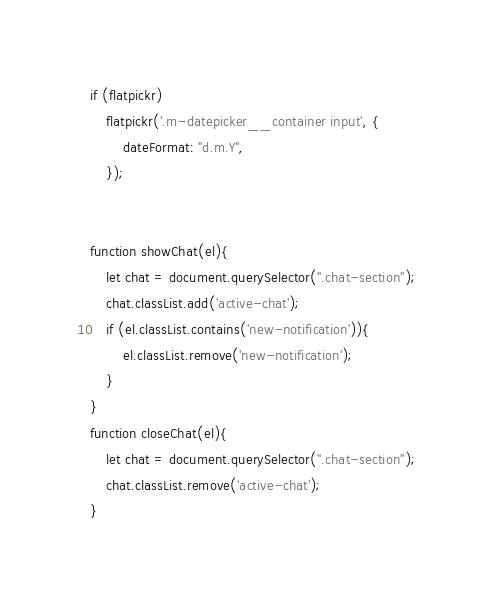Convert code to text. <code><loc_0><loc_0><loc_500><loc_500><_JavaScript_>if (flatpickr)
    flatpickr('.m-datepicker__container input', {
        dateFormat: "d.m.Y",
    });


function showChat(el){
    let chat = document.querySelector(".chat-section");
    chat.classList.add('active-chat');
    if (el.classList.contains('new-notification')){
        el.classList.remove('new-notification');
    }
}
function closeChat(el){
    let chat = document.querySelector(".chat-section");
    chat.classList.remove('active-chat');
}</code> 